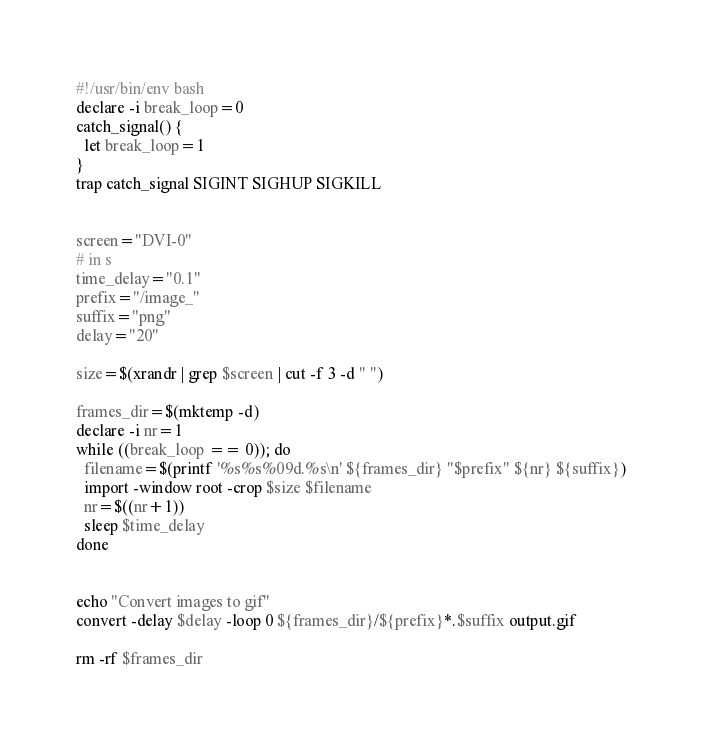<code> <loc_0><loc_0><loc_500><loc_500><_Bash_>#!/usr/bin/env bash
declare -i break_loop=0
catch_signal() {
  let break_loop=1
}
trap catch_signal SIGINT SIGHUP SIGKILL


screen="DVI-0"
# in s
time_delay="0.1"
prefix="/image_"
suffix="png"
delay="20"

size=$(xrandr | grep $screen | cut -f 3 -d " ")

frames_dir=$(mktemp -d)
declare -i nr=1
while ((break_loop == 0)); do
  filename=$(printf '%s%s%09d.%s\n' ${frames_dir} "$prefix" ${nr} ${suffix})
  import -window root -crop $size $filename
  nr=$((nr+1))
  sleep $time_delay
done


echo "Convert images to gif"
convert -delay $delay -loop 0 ${frames_dir}/${prefix}*.$suffix output.gif

rm -rf $frames_dir

</code> 